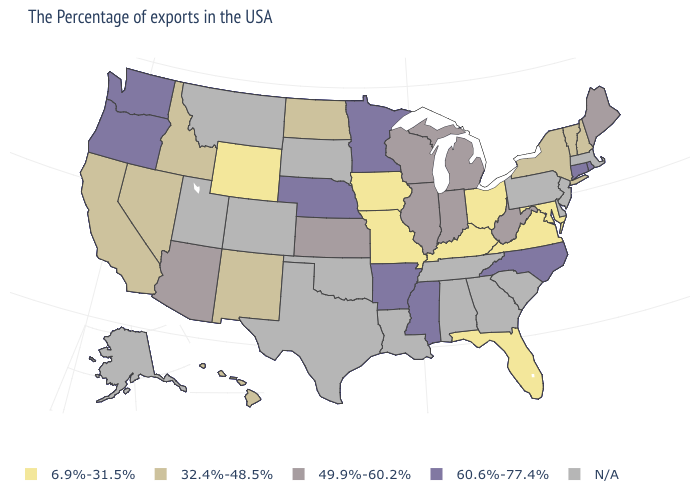What is the lowest value in the Northeast?
Answer briefly. 32.4%-48.5%. Which states have the lowest value in the West?
Short answer required. Wyoming. Is the legend a continuous bar?
Write a very short answer. No. What is the highest value in the USA?
Write a very short answer. 60.6%-77.4%. Does the first symbol in the legend represent the smallest category?
Quick response, please. Yes. Name the states that have a value in the range N/A?
Keep it brief. Massachusetts, New Jersey, Delaware, Pennsylvania, South Carolina, Georgia, Alabama, Tennessee, Louisiana, Oklahoma, Texas, South Dakota, Colorado, Utah, Montana, Alaska. Does the first symbol in the legend represent the smallest category?
Concise answer only. Yes. How many symbols are there in the legend?
Quick response, please. 5. What is the lowest value in states that border North Dakota?
Short answer required. 60.6%-77.4%. Does Oregon have the highest value in the USA?
Be succinct. Yes. What is the value of Maine?
Give a very brief answer. 49.9%-60.2%. Which states hav the highest value in the Northeast?
Give a very brief answer. Rhode Island, Connecticut. Does North Dakota have the lowest value in the MidWest?
Short answer required. No. 